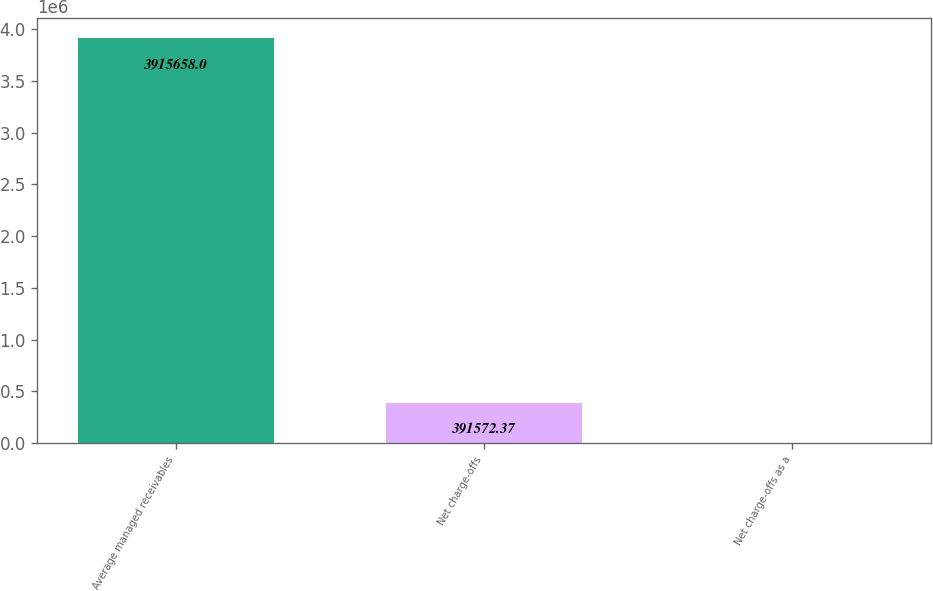Convert chart. <chart><loc_0><loc_0><loc_500><loc_500><bar_chart><fcel>Average managed receivables<fcel>Net charge-offs<fcel>Net charge-offs as a<nl><fcel>3.91566e+06<fcel>391572<fcel>7.3<nl></chart> 